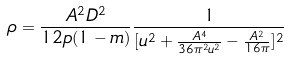<formula> <loc_0><loc_0><loc_500><loc_500>\rho = \frac { A ^ { 2 } D ^ { 2 } } { 1 2 p ( 1 - m ) } \frac { 1 } { [ u ^ { 2 } + \frac { A ^ { 4 } } { 3 6 \pi ^ { 2 } u ^ { 2 } } - \frac { A ^ { 2 } } { 1 6 \pi } ] ^ { 2 } }</formula> 